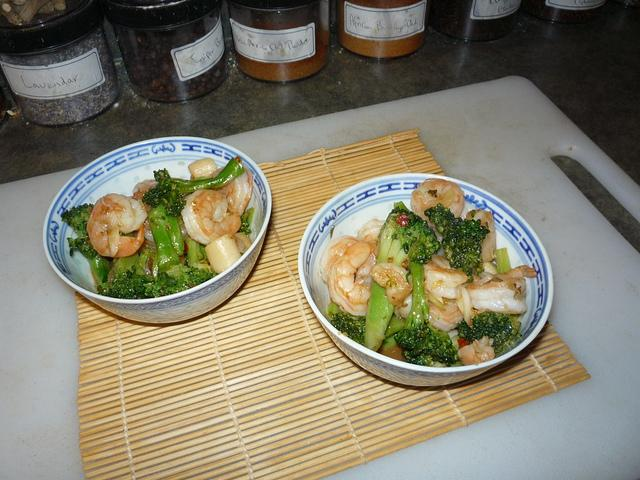If this is Chinese food how was it most likely cooked?

Choices:
A) barbecue grill
B) pan seared
C) stir fried
D) oven stir fried 